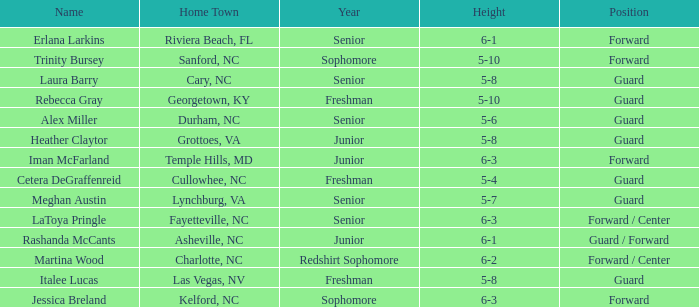In what year of school is the forward Iman McFarland? Junior. 